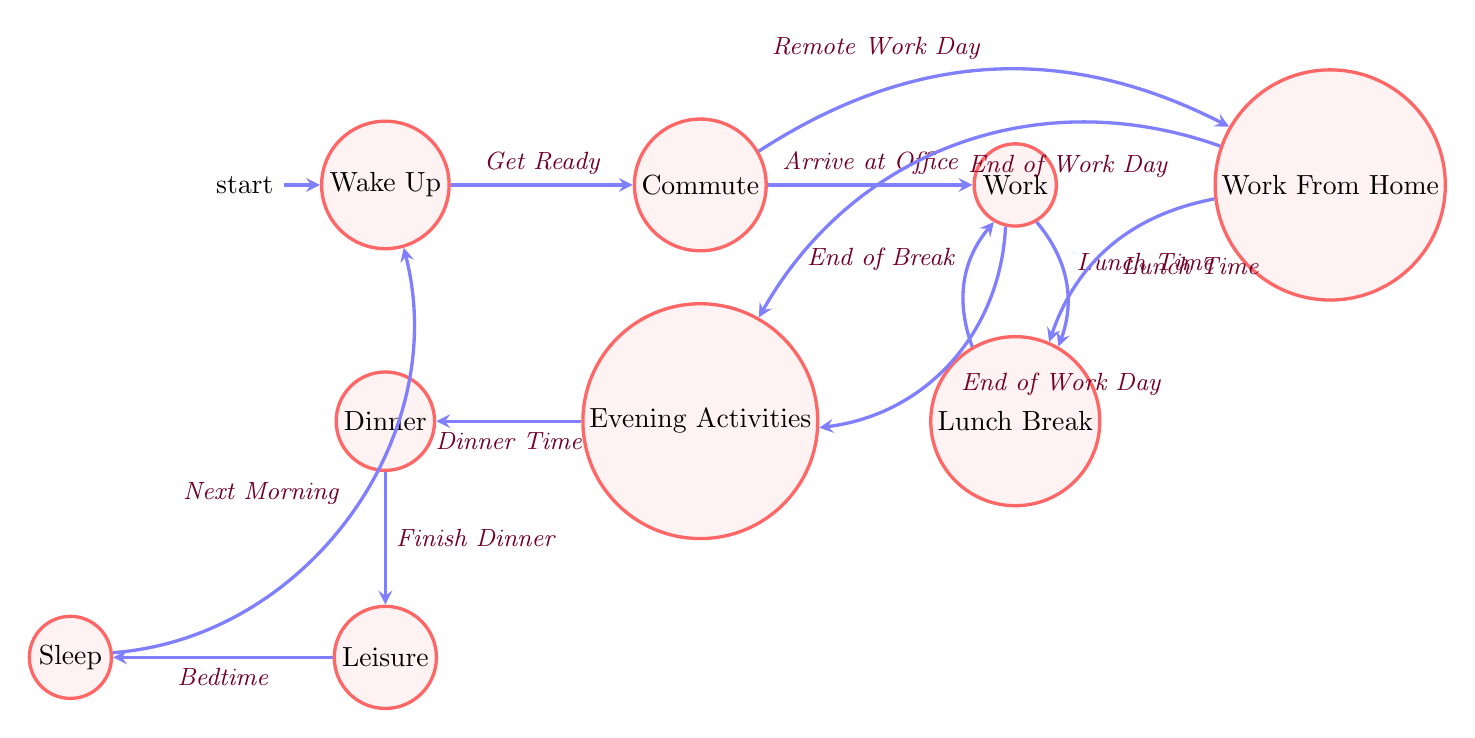What is the initial state of the diagram? The initial state is the first node labeled as "Wake Up". It is indicated as the starting point in the diagram, confirming that this is where the process begins for a generic work week schedule.
Answer: Wake Up How many states are present in the finite state machine? Counting each named state in the diagram, there are ten unique states: Wake Up, Commute, Work, Lunch Break, Work From Home, Work (Post-Lunch), Commute Home, Evening Activities, Dinner, and Leisure.
Answer: 10 What condition leads from "Work" to "Lunch Break"? The condition required to transition from "Work" to "Lunch Break" is labeled as "Lunch Time". This condition clearly indicates the timing, establishing when a worker takes their lunch.
Answer: Lunch Time What happens after "Evening Activities"? After the "Evening Activities" state, the next transition occurs to "Dinner", signifying that dinner is the subsequent event following evening activities, as indicated by the directed edge in the diagram.
Answer: Dinner What is the last state before the process resets? The last state before the process returns to the beginning is "Sleep". The transition is indicated by the condition "Next Morning", meaning that when the day ends in sleep, the cycle will restart the next morning.
Answer: Sleep Which nodes can be reached directly from the "Commute" state? From the "Commute" state, you can directly transition to "Work" upon arriving at the office or to "Work From Home" if it is a remote workday. Both transitions are dependent directly on conditions related to whether the person is commuting to the office or working remotely.
Answer: Work, Work From Home How many transitions lead into the "Lunch Break" state? The "Lunch Break" state has two incoming transitions: one from "Work" and another from "Work From Home". Each transition depends on the timing of lunch regardless of location, thus, there are two ways to enter this state.
Answer: 2 What condition is required to transition from "Sleep" back to "Wake Up"? The transition from "Sleep" back to "Wake Up" occurs when it is the "Next Morning". This condition indicates the cyclic nature of the daily schedule, representing the start of a new day.
Answer: Next Morning What state follows "Dinner" in the sequence? Following "Dinner", the next state is "Leisure", as shown by the transition labeled "Finish Dinner", indicating that after having dinner, the activity flows into leisure time.
Answer: Leisure 